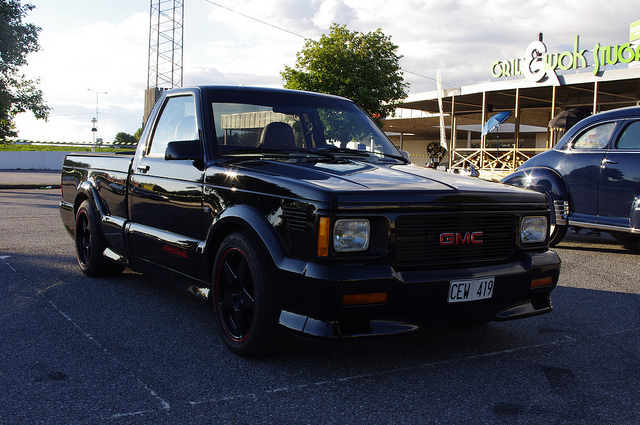Identify and read out the text in this image. GMC CEW 419 wok STUO E 